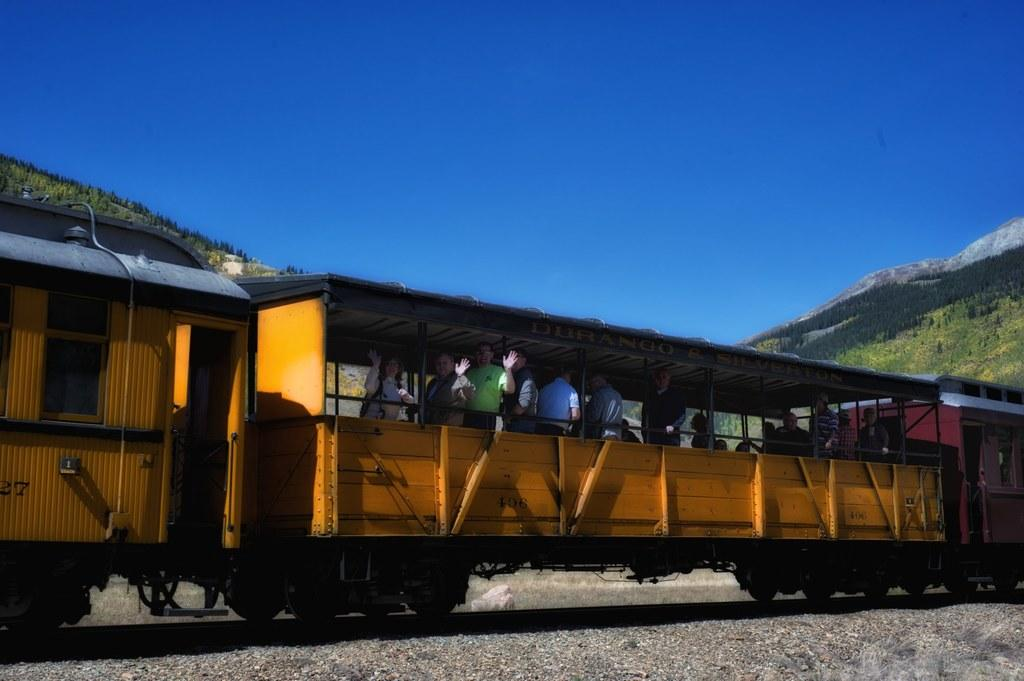What is the main subject of the image? The main subject of the image is a train. What can be observed about the train's position in the image? The train is on a track. What is the color of the train? The train is yellow in color. Can you describe the people inside the train? There are people inside the train, but their specific actions or appearances cannot be determined from the image. What is visible in the background of the image? In the background of the image, there are mountains and trees. What is the color of the sky in the image? The sky is blue in color. What type of nut is being used to blow the train's whistle in the image? There is no nut or whistle present in the image; it is a train on a track with people inside. 